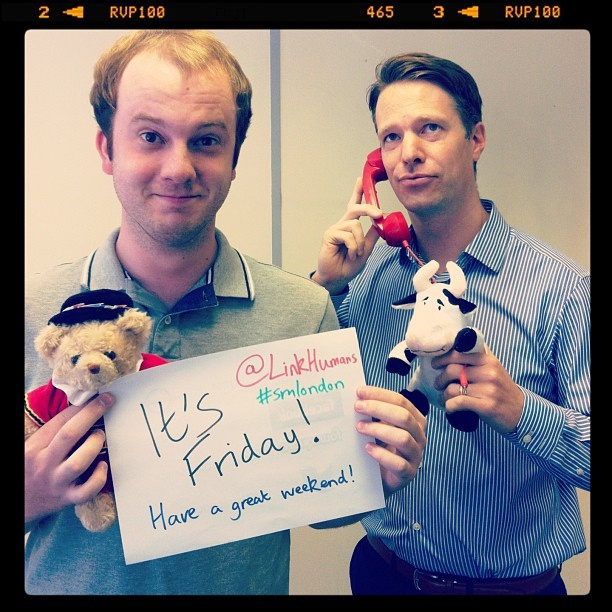Describe the objects in this image and their specific colors. I can see people in black, lightgray, lightpink, darkgray, and tan tones, people in black, navy, gray, blue, and lightgray tones, and teddy bear in black, tan, gray, and darkgray tones in this image. 